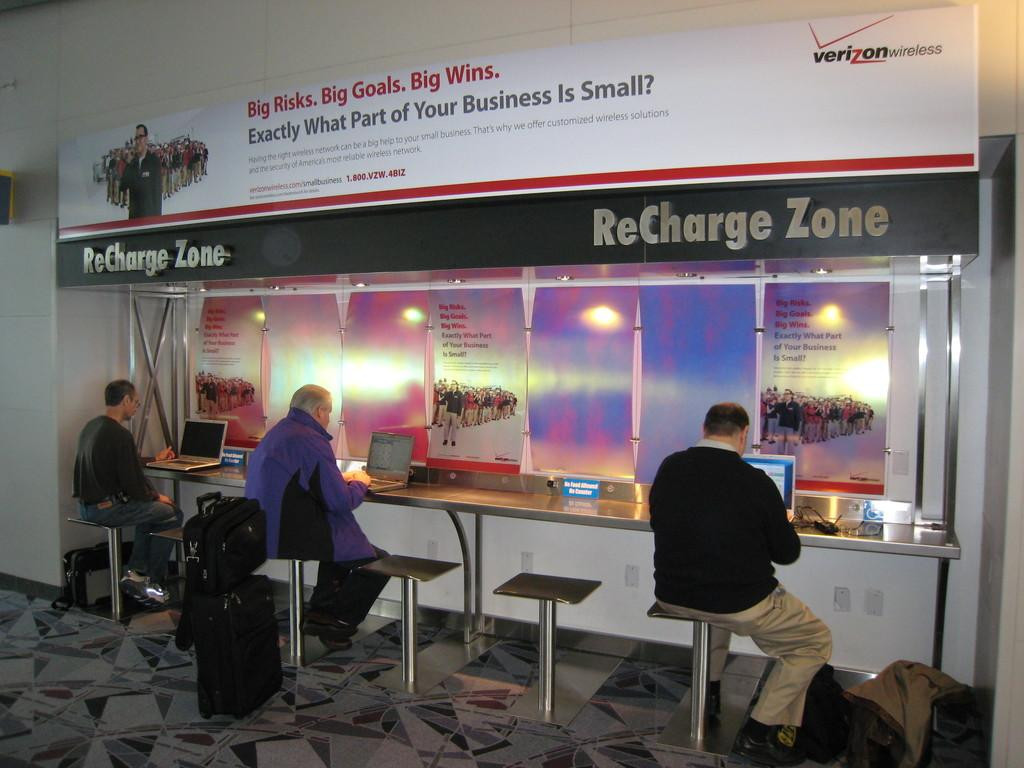<image>
Offer a succinct explanation of the picture presented. ReCharge Zone is advertised over this electronics area. 